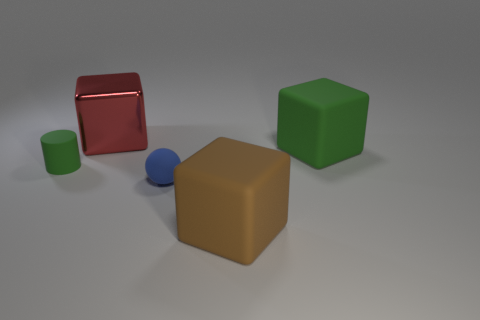How many objects are green matte objects or objects that are behind the matte cylinder?
Provide a succinct answer. 3. Are there fewer large brown things than things?
Offer a terse response. Yes. The small thing left of the object behind the large rubber object behind the large brown object is what color?
Keep it short and to the point. Green. Is the red object made of the same material as the green cube?
Your answer should be compact. No. There is a tiny ball; what number of small blue rubber things are on the right side of it?
Offer a terse response. 0. There is a metal object that is the same shape as the brown rubber thing; what size is it?
Offer a terse response. Large. How many red objects are tiny shiny cylinders or metallic cubes?
Offer a terse response. 1. How many green cylinders are in front of the thing to the right of the brown matte object?
Give a very brief answer. 1. How many other objects are the same shape as the large metallic thing?
Offer a very short reply. 2. There is a block that is the same color as the matte cylinder; what material is it?
Provide a succinct answer. Rubber. 